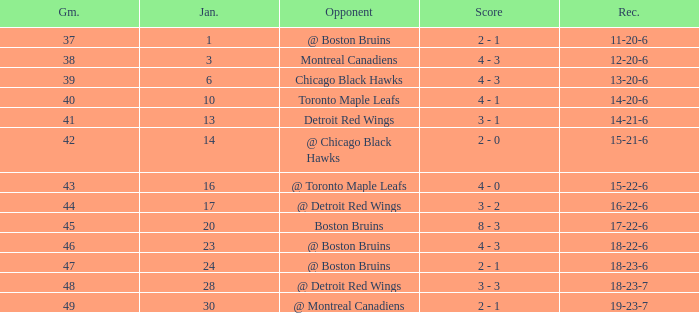What day in January was the game greater than 49 and had @ Montreal Canadiens as opponents? None. 